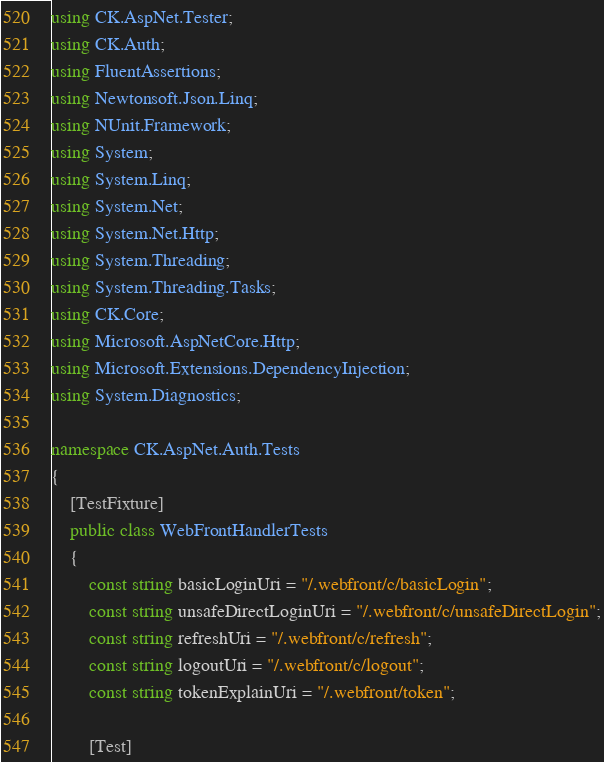Convert code to text. <code><loc_0><loc_0><loc_500><loc_500><_C#_>using CK.AspNet.Tester;
using CK.Auth;
using FluentAssertions;
using Newtonsoft.Json.Linq;
using NUnit.Framework;
using System;
using System.Linq;
using System.Net;
using System.Net.Http;
using System.Threading;
using System.Threading.Tasks;
using CK.Core;
using Microsoft.AspNetCore.Http;
using Microsoft.Extensions.DependencyInjection;
using System.Diagnostics;

namespace CK.AspNet.Auth.Tests
{
    [TestFixture]
    public class WebFrontHandlerTests
    {
        const string basicLoginUri = "/.webfront/c/basicLogin";
        const string unsafeDirectLoginUri = "/.webfront/c/unsafeDirectLogin";
        const string refreshUri = "/.webfront/c/refresh";
        const string logoutUri = "/.webfront/c/logout";
        const string tokenExplainUri = "/.webfront/token";

        [Test]</code> 